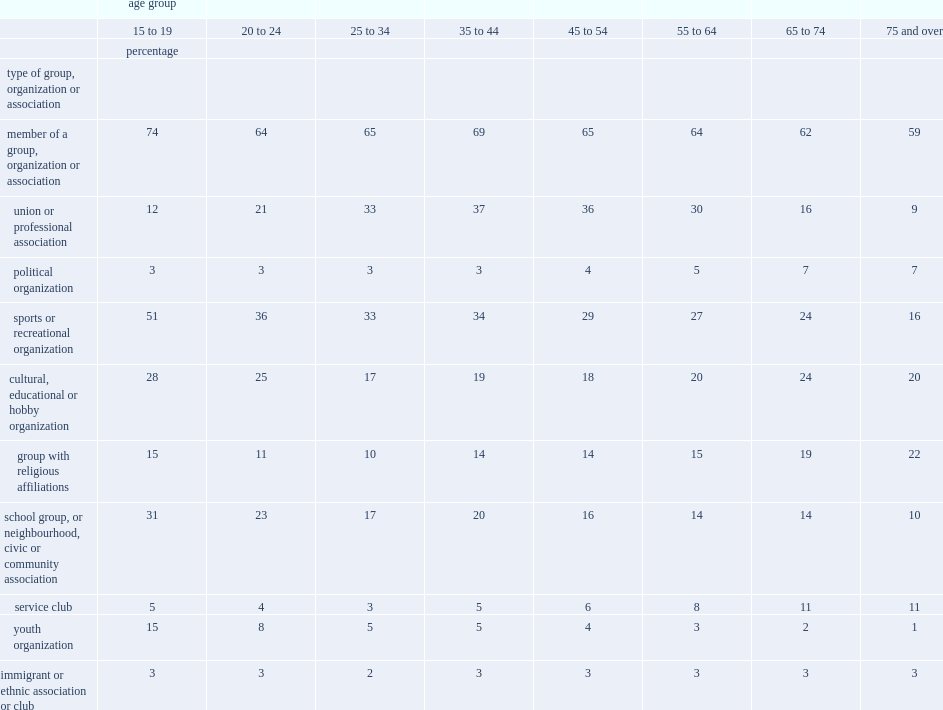How many percentage points was youth aged 15 to 19 part of a group, organization or association in 2013? 74.0. How many percentage points was youth aged 20 to 24 part of a group, organization or association in 2013? 64.0. How many percentage points was youth aged 45 to 54 part of a group, organization or association in 2013? 65.0. How many percentage points was individuals aged 65 to 74 part of a group, organization or association in 2013? 62.0. 